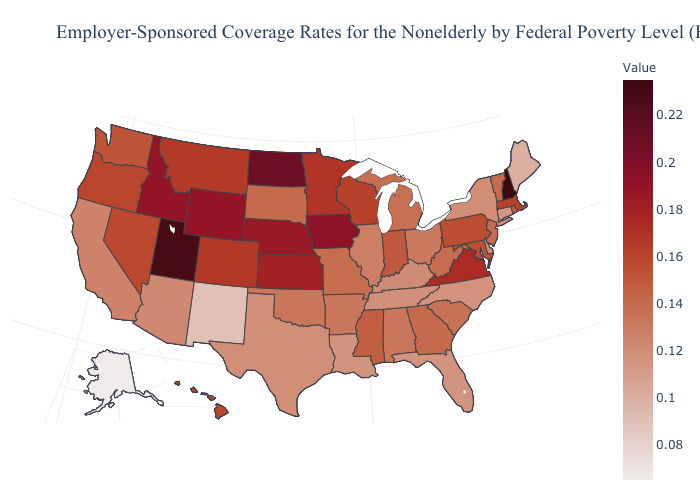Does Montana have the lowest value in the USA?
Short answer required. No. Which states have the highest value in the USA?
Be succinct. New Hampshire. Does Louisiana have the highest value in the South?
Keep it brief. No. Which states have the lowest value in the West?
Answer briefly. Alaska. Among the states that border Georgia , does South Carolina have the highest value?
Write a very short answer. Yes. 